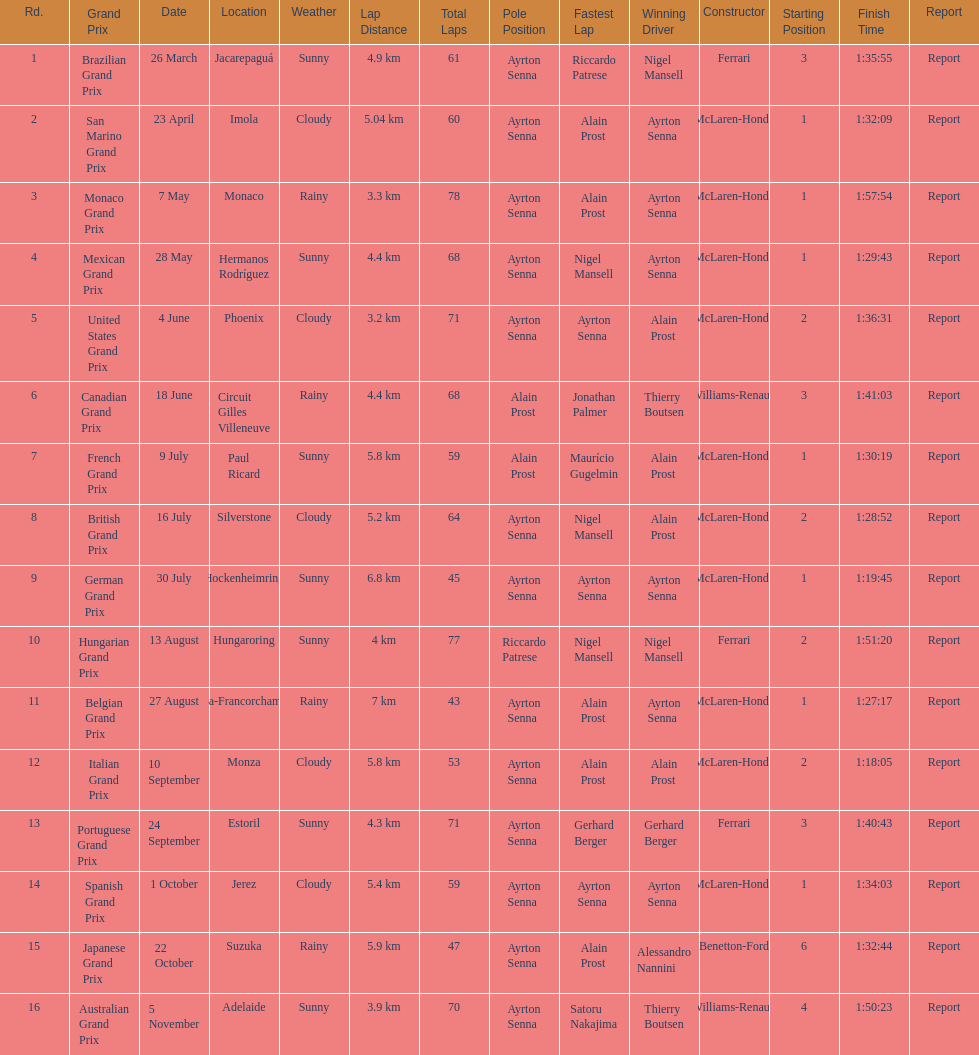How many races occurred before alain prost won a pole position? 5. 